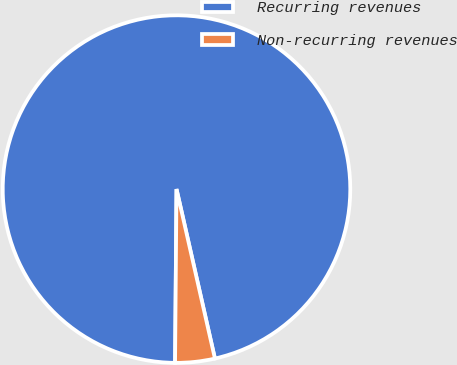<chart> <loc_0><loc_0><loc_500><loc_500><pie_chart><fcel>Recurring revenues<fcel>Non-recurring revenues<nl><fcel>96.32%<fcel>3.68%<nl></chart> 